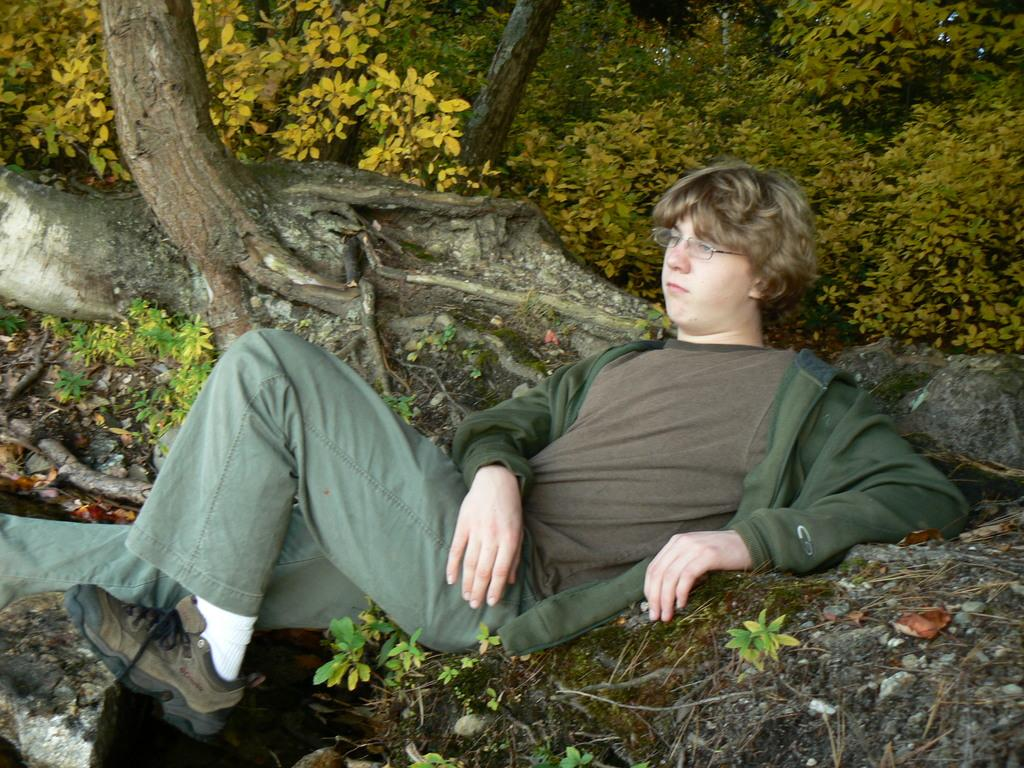What is the main subject of the image? There is a person in the image. What is the person wearing in the image? The person is wearing specs in the image. What is the person's position in the image? The person is lying on the ground in the image. What can be seen in the background of the image? There are trees in the background of the image. What type of lettuce can be seen growing on the person's skin in the image? There is no lettuce or any reference to skin in the image; it features a person lying on the ground with specs on. 